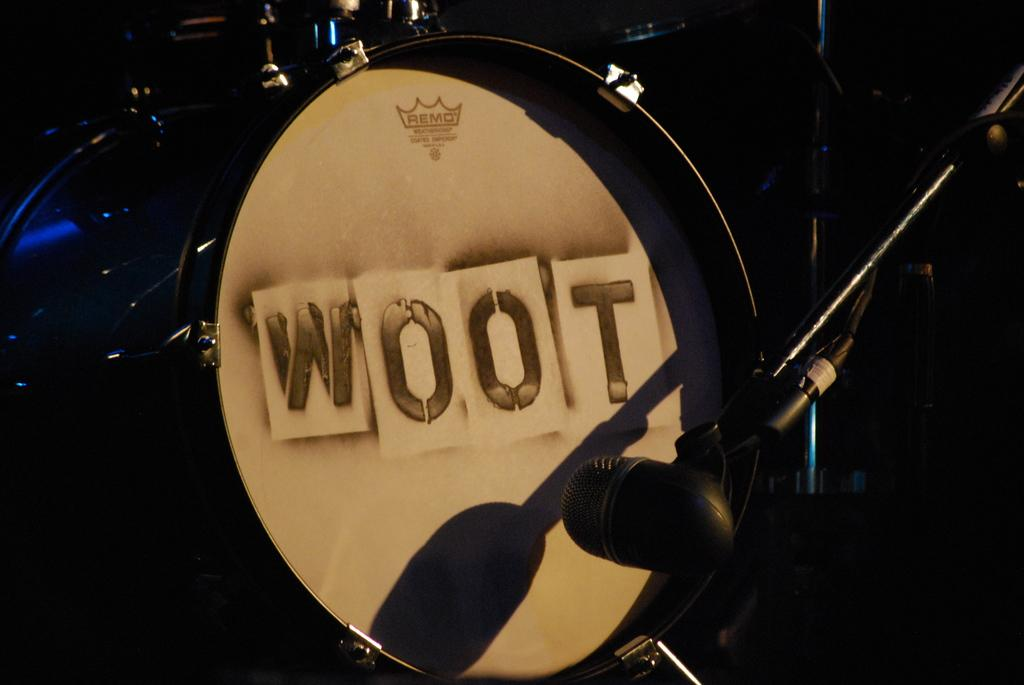What musical instrument is present in the image? There is a drum in the image. How is the drum positioned in relation to the microphone? The drum is in front of a microphone. What can be inferred about the lighting conditions in the image? The background of the image is dark. What type of cracker is being used as a drumstick in the image? There is no cracker or drumstick present in the image; it only features a drum and a microphone. Can you tell me how many times the grandfather claps his hands in the image? There is no grandfather or clapping in the image; it only features a drum and a microphone. 